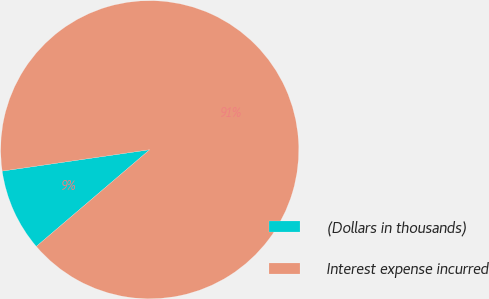Convert chart. <chart><loc_0><loc_0><loc_500><loc_500><pie_chart><fcel>(Dollars in thousands)<fcel>Interest expense incurred<nl><fcel>8.95%<fcel>91.05%<nl></chart> 